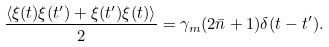Convert formula to latex. <formula><loc_0><loc_0><loc_500><loc_500>\frac { \langle \xi ( t ) \xi ( t ^ { \prime } ) + \xi ( t ^ { \prime } ) \xi ( t ) \rangle } { 2 } = \gamma _ { m } ( 2 \bar { n } + 1 ) \delta ( t - t ^ { \prime } ) .</formula> 